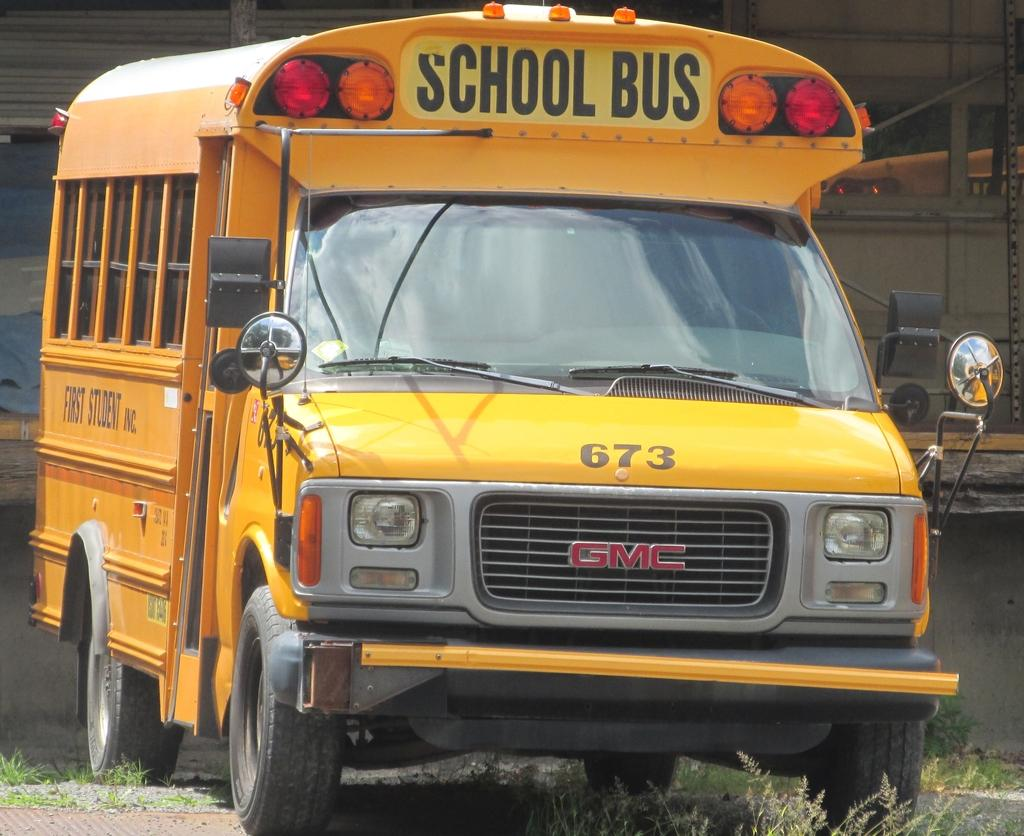What is the main subject of the image? The main subject of the image is a bus. What color is the bus? The bus is yellow in color. Are there any markings or text on the bus? Yes, there are words and numbers written on the bus. What can be seen on the ground in the image? There is grass on the ground in the image. How do the children react to the note left on the bus in the image? There is no note or children present in the image; it only features a yellow bus with words and numbers on it, and grass on the ground. 